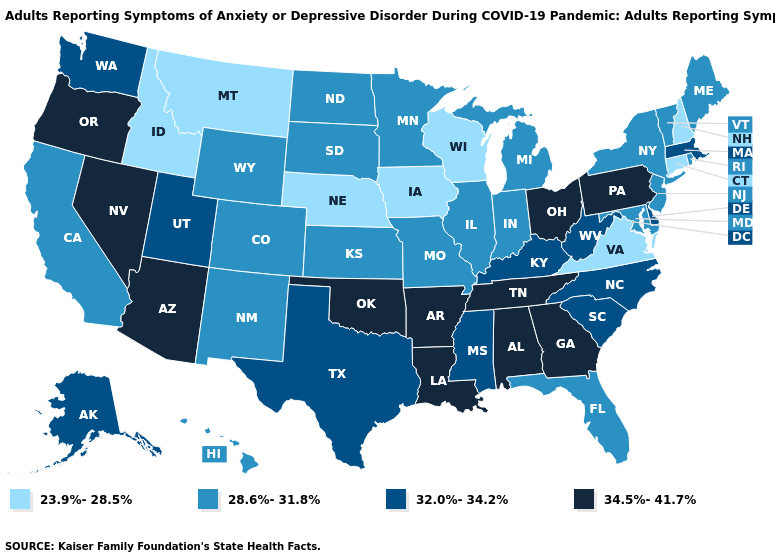What is the highest value in the USA?
Write a very short answer. 34.5%-41.7%. Which states hav the highest value in the MidWest?
Quick response, please. Ohio. What is the value of New York?
Write a very short answer. 28.6%-31.8%. What is the value of New Hampshire?
Keep it brief. 23.9%-28.5%. What is the value of North Carolina?
Quick response, please. 32.0%-34.2%. Does Wisconsin have the lowest value in the USA?
Concise answer only. Yes. Among the states that border Vermont , does New York have the lowest value?
Short answer required. No. Does Idaho have the lowest value in the USA?
Keep it brief. Yes. Does Connecticut have a lower value than Montana?
Concise answer only. No. Which states have the lowest value in the West?
Be succinct. Idaho, Montana. Name the states that have a value in the range 34.5%-41.7%?
Keep it brief. Alabama, Arizona, Arkansas, Georgia, Louisiana, Nevada, Ohio, Oklahoma, Oregon, Pennsylvania, Tennessee. Does Arkansas have the highest value in the USA?
Keep it brief. Yes. What is the highest value in the South ?
Keep it brief. 34.5%-41.7%. Name the states that have a value in the range 28.6%-31.8%?
Concise answer only. California, Colorado, Florida, Hawaii, Illinois, Indiana, Kansas, Maine, Maryland, Michigan, Minnesota, Missouri, New Jersey, New Mexico, New York, North Dakota, Rhode Island, South Dakota, Vermont, Wyoming. 